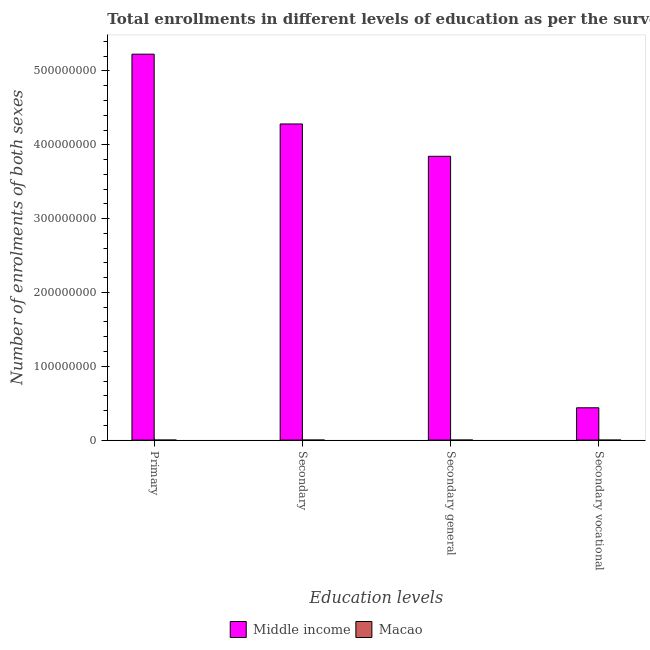Are the number of bars on each tick of the X-axis equal?
Your answer should be compact. Yes. What is the label of the 4th group of bars from the left?
Ensure brevity in your answer.  Secondary vocational. What is the number of enrolments in secondary general education in Macao?
Keep it short and to the point. 3.23e+04. Across all countries, what is the maximum number of enrolments in secondary vocational education?
Keep it short and to the point. 4.38e+07. Across all countries, what is the minimum number of enrolments in secondary vocational education?
Your answer should be very brief. 1605. In which country was the number of enrolments in secondary general education maximum?
Provide a succinct answer. Middle income. In which country was the number of enrolments in secondary education minimum?
Offer a very short reply. Macao. What is the total number of enrolments in secondary general education in the graph?
Your response must be concise. 3.84e+08. What is the difference between the number of enrolments in secondary general education in Macao and that in Middle income?
Provide a short and direct response. -3.84e+08. What is the difference between the number of enrolments in secondary general education in Middle income and the number of enrolments in secondary education in Macao?
Offer a very short reply. 3.84e+08. What is the average number of enrolments in secondary education per country?
Your answer should be compact. 2.14e+08. What is the difference between the number of enrolments in secondary vocational education and number of enrolments in secondary general education in Macao?
Keep it short and to the point. -3.07e+04. What is the ratio of the number of enrolments in secondary general education in Macao to that in Middle income?
Offer a very short reply. 8.405706266605405e-5. Is the difference between the number of enrolments in secondary education in Macao and Middle income greater than the difference between the number of enrolments in primary education in Macao and Middle income?
Provide a short and direct response. Yes. What is the difference between the highest and the second highest number of enrolments in secondary education?
Make the answer very short. 4.28e+08. What is the difference between the highest and the lowest number of enrolments in secondary education?
Make the answer very short. 4.28e+08. Is it the case that in every country, the sum of the number of enrolments in secondary education and number of enrolments in secondary general education is greater than the sum of number of enrolments in secondary vocational education and number of enrolments in primary education?
Make the answer very short. No. What does the 1st bar from the left in Secondary represents?
Ensure brevity in your answer.  Middle income. What does the 2nd bar from the right in Secondary general represents?
Ensure brevity in your answer.  Middle income. Is it the case that in every country, the sum of the number of enrolments in primary education and number of enrolments in secondary education is greater than the number of enrolments in secondary general education?
Provide a succinct answer. Yes. How many bars are there?
Your response must be concise. 8. Are all the bars in the graph horizontal?
Keep it short and to the point. No. What is the difference between two consecutive major ticks on the Y-axis?
Ensure brevity in your answer.  1.00e+08. Are the values on the major ticks of Y-axis written in scientific E-notation?
Offer a very short reply. No. Does the graph contain any zero values?
Give a very brief answer. No. Where does the legend appear in the graph?
Your answer should be compact. Bottom center. How many legend labels are there?
Make the answer very short. 2. How are the legend labels stacked?
Ensure brevity in your answer.  Horizontal. What is the title of the graph?
Your answer should be compact. Total enrollments in different levels of education as per the survey of 2013. Does "Sint Maarten (Dutch part)" appear as one of the legend labels in the graph?
Provide a short and direct response. No. What is the label or title of the X-axis?
Your answer should be very brief. Education levels. What is the label or title of the Y-axis?
Offer a terse response. Number of enrolments of both sexes. What is the Number of enrolments of both sexes in Middle income in Primary?
Ensure brevity in your answer.  5.23e+08. What is the Number of enrolments of both sexes in Macao in Primary?
Your answer should be very brief. 2.22e+04. What is the Number of enrolments of both sexes in Middle income in Secondary?
Make the answer very short. 4.28e+08. What is the Number of enrolments of both sexes of Macao in Secondary?
Offer a terse response. 3.39e+04. What is the Number of enrolments of both sexes of Middle income in Secondary general?
Give a very brief answer. 3.84e+08. What is the Number of enrolments of both sexes of Macao in Secondary general?
Offer a terse response. 3.23e+04. What is the Number of enrolments of both sexes of Middle income in Secondary vocational?
Give a very brief answer. 4.38e+07. What is the Number of enrolments of both sexes in Macao in Secondary vocational?
Provide a succinct answer. 1605. Across all Education levels, what is the maximum Number of enrolments of both sexes in Middle income?
Provide a succinct answer. 5.23e+08. Across all Education levels, what is the maximum Number of enrolments of both sexes of Macao?
Your answer should be very brief. 3.39e+04. Across all Education levels, what is the minimum Number of enrolments of both sexes of Middle income?
Make the answer very short. 4.38e+07. Across all Education levels, what is the minimum Number of enrolments of both sexes in Macao?
Offer a terse response. 1605. What is the total Number of enrolments of both sexes of Middle income in the graph?
Offer a very short reply. 1.38e+09. What is the total Number of enrolments of both sexes of Macao in the graph?
Give a very brief answer. 9.01e+04. What is the difference between the Number of enrolments of both sexes of Middle income in Primary and that in Secondary?
Make the answer very short. 9.45e+07. What is the difference between the Number of enrolments of both sexes of Macao in Primary and that in Secondary?
Offer a terse response. -1.17e+04. What is the difference between the Number of enrolments of both sexes of Middle income in Primary and that in Secondary general?
Give a very brief answer. 1.38e+08. What is the difference between the Number of enrolments of both sexes in Macao in Primary and that in Secondary general?
Offer a terse response. -1.01e+04. What is the difference between the Number of enrolments of both sexes of Middle income in Primary and that in Secondary vocational?
Provide a succinct answer. 4.79e+08. What is the difference between the Number of enrolments of both sexes in Macao in Primary and that in Secondary vocational?
Provide a succinct answer. 2.06e+04. What is the difference between the Number of enrolments of both sexes in Middle income in Secondary and that in Secondary general?
Offer a terse response. 4.38e+07. What is the difference between the Number of enrolments of both sexes in Macao in Secondary and that in Secondary general?
Offer a very short reply. 1605. What is the difference between the Number of enrolments of both sexes in Middle income in Secondary and that in Secondary vocational?
Keep it short and to the point. 3.84e+08. What is the difference between the Number of enrolments of both sexes of Macao in Secondary and that in Secondary vocational?
Give a very brief answer. 3.23e+04. What is the difference between the Number of enrolments of both sexes of Middle income in Secondary general and that in Secondary vocational?
Offer a terse response. 3.41e+08. What is the difference between the Number of enrolments of both sexes of Macao in Secondary general and that in Secondary vocational?
Provide a succinct answer. 3.07e+04. What is the difference between the Number of enrolments of both sexes of Middle income in Primary and the Number of enrolments of both sexes of Macao in Secondary?
Offer a very short reply. 5.23e+08. What is the difference between the Number of enrolments of both sexes of Middle income in Primary and the Number of enrolments of both sexes of Macao in Secondary general?
Offer a terse response. 5.23e+08. What is the difference between the Number of enrolments of both sexes of Middle income in Primary and the Number of enrolments of both sexes of Macao in Secondary vocational?
Provide a succinct answer. 5.23e+08. What is the difference between the Number of enrolments of both sexes in Middle income in Secondary and the Number of enrolments of both sexes in Macao in Secondary general?
Keep it short and to the point. 4.28e+08. What is the difference between the Number of enrolments of both sexes in Middle income in Secondary and the Number of enrolments of both sexes in Macao in Secondary vocational?
Provide a succinct answer. 4.28e+08. What is the difference between the Number of enrolments of both sexes in Middle income in Secondary general and the Number of enrolments of both sexes in Macao in Secondary vocational?
Your answer should be compact. 3.84e+08. What is the average Number of enrolments of both sexes of Middle income per Education levels?
Your response must be concise. 3.45e+08. What is the average Number of enrolments of both sexes in Macao per Education levels?
Your answer should be very brief. 2.25e+04. What is the difference between the Number of enrolments of both sexes in Middle income and Number of enrolments of both sexes in Macao in Primary?
Ensure brevity in your answer.  5.23e+08. What is the difference between the Number of enrolments of both sexes in Middle income and Number of enrolments of both sexes in Macao in Secondary?
Give a very brief answer. 4.28e+08. What is the difference between the Number of enrolments of both sexes of Middle income and Number of enrolments of both sexes of Macao in Secondary general?
Ensure brevity in your answer.  3.84e+08. What is the difference between the Number of enrolments of both sexes of Middle income and Number of enrolments of both sexes of Macao in Secondary vocational?
Your answer should be compact. 4.38e+07. What is the ratio of the Number of enrolments of both sexes in Middle income in Primary to that in Secondary?
Your answer should be compact. 1.22. What is the ratio of the Number of enrolments of both sexes in Macao in Primary to that in Secondary?
Give a very brief answer. 0.66. What is the ratio of the Number of enrolments of both sexes in Middle income in Primary to that in Secondary general?
Your answer should be very brief. 1.36. What is the ratio of the Number of enrolments of both sexes in Macao in Primary to that in Secondary general?
Give a very brief answer. 0.69. What is the ratio of the Number of enrolments of both sexes in Middle income in Primary to that in Secondary vocational?
Provide a succinct answer. 11.94. What is the ratio of the Number of enrolments of both sexes in Macao in Primary to that in Secondary vocational?
Give a very brief answer. 13.85. What is the ratio of the Number of enrolments of both sexes of Middle income in Secondary to that in Secondary general?
Your answer should be compact. 1.11. What is the ratio of the Number of enrolments of both sexes of Macao in Secondary to that in Secondary general?
Your response must be concise. 1.05. What is the ratio of the Number of enrolments of both sexes of Middle income in Secondary to that in Secondary vocational?
Provide a short and direct response. 9.78. What is the ratio of the Number of enrolments of both sexes in Macao in Secondary to that in Secondary vocational?
Offer a very short reply. 21.13. What is the ratio of the Number of enrolments of both sexes of Middle income in Secondary general to that in Secondary vocational?
Ensure brevity in your answer.  8.78. What is the ratio of the Number of enrolments of both sexes of Macao in Secondary general to that in Secondary vocational?
Offer a terse response. 20.13. What is the difference between the highest and the second highest Number of enrolments of both sexes in Middle income?
Offer a terse response. 9.45e+07. What is the difference between the highest and the second highest Number of enrolments of both sexes of Macao?
Provide a succinct answer. 1605. What is the difference between the highest and the lowest Number of enrolments of both sexes in Middle income?
Make the answer very short. 4.79e+08. What is the difference between the highest and the lowest Number of enrolments of both sexes of Macao?
Provide a short and direct response. 3.23e+04. 